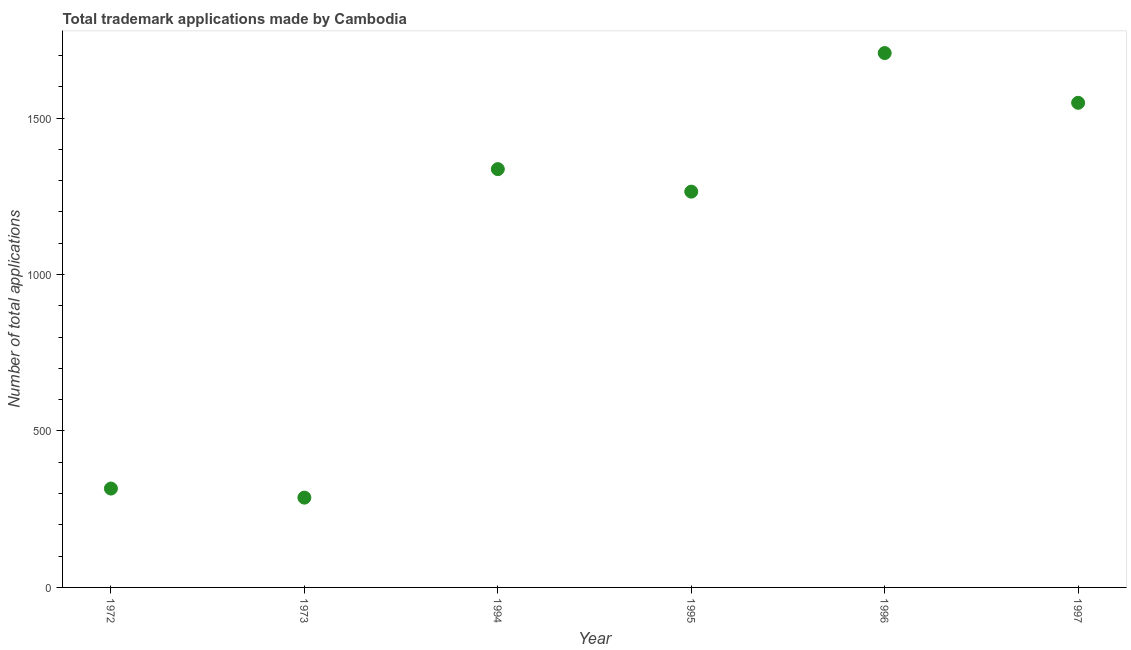What is the number of trademark applications in 1994?
Keep it short and to the point. 1337. Across all years, what is the maximum number of trademark applications?
Your answer should be compact. 1708. Across all years, what is the minimum number of trademark applications?
Offer a very short reply. 287. In which year was the number of trademark applications minimum?
Your answer should be very brief. 1973. What is the sum of the number of trademark applications?
Offer a terse response. 6462. What is the difference between the number of trademark applications in 1972 and 1997?
Provide a succinct answer. -1233. What is the average number of trademark applications per year?
Provide a succinct answer. 1077. What is the median number of trademark applications?
Keep it short and to the point. 1301. In how many years, is the number of trademark applications greater than 1000 ?
Your answer should be compact. 4. Do a majority of the years between 1994 and 1995 (inclusive) have number of trademark applications greater than 200 ?
Your response must be concise. Yes. What is the ratio of the number of trademark applications in 1972 to that in 1994?
Provide a short and direct response. 0.24. Is the number of trademark applications in 1972 less than that in 1995?
Offer a terse response. Yes. Is the difference between the number of trademark applications in 1996 and 1997 greater than the difference between any two years?
Your response must be concise. No. What is the difference between the highest and the second highest number of trademark applications?
Provide a succinct answer. 159. Is the sum of the number of trademark applications in 1972 and 1997 greater than the maximum number of trademark applications across all years?
Your response must be concise. Yes. What is the difference between the highest and the lowest number of trademark applications?
Ensure brevity in your answer.  1421. Does the number of trademark applications monotonically increase over the years?
Give a very brief answer. No. Does the graph contain any zero values?
Offer a terse response. No. What is the title of the graph?
Make the answer very short. Total trademark applications made by Cambodia. What is the label or title of the X-axis?
Give a very brief answer. Year. What is the label or title of the Y-axis?
Make the answer very short. Number of total applications. What is the Number of total applications in 1972?
Ensure brevity in your answer.  316. What is the Number of total applications in 1973?
Keep it short and to the point. 287. What is the Number of total applications in 1994?
Your answer should be compact. 1337. What is the Number of total applications in 1995?
Make the answer very short. 1265. What is the Number of total applications in 1996?
Your response must be concise. 1708. What is the Number of total applications in 1997?
Keep it short and to the point. 1549. What is the difference between the Number of total applications in 1972 and 1994?
Your answer should be compact. -1021. What is the difference between the Number of total applications in 1972 and 1995?
Your response must be concise. -949. What is the difference between the Number of total applications in 1972 and 1996?
Offer a terse response. -1392. What is the difference between the Number of total applications in 1972 and 1997?
Offer a very short reply. -1233. What is the difference between the Number of total applications in 1973 and 1994?
Offer a terse response. -1050. What is the difference between the Number of total applications in 1973 and 1995?
Provide a short and direct response. -978. What is the difference between the Number of total applications in 1973 and 1996?
Offer a very short reply. -1421. What is the difference between the Number of total applications in 1973 and 1997?
Provide a short and direct response. -1262. What is the difference between the Number of total applications in 1994 and 1995?
Provide a short and direct response. 72. What is the difference between the Number of total applications in 1994 and 1996?
Provide a short and direct response. -371. What is the difference between the Number of total applications in 1994 and 1997?
Offer a very short reply. -212. What is the difference between the Number of total applications in 1995 and 1996?
Your answer should be very brief. -443. What is the difference between the Number of total applications in 1995 and 1997?
Make the answer very short. -284. What is the difference between the Number of total applications in 1996 and 1997?
Your answer should be compact. 159. What is the ratio of the Number of total applications in 1972 to that in 1973?
Give a very brief answer. 1.1. What is the ratio of the Number of total applications in 1972 to that in 1994?
Offer a very short reply. 0.24. What is the ratio of the Number of total applications in 1972 to that in 1996?
Provide a short and direct response. 0.18. What is the ratio of the Number of total applications in 1972 to that in 1997?
Your answer should be compact. 0.2. What is the ratio of the Number of total applications in 1973 to that in 1994?
Ensure brevity in your answer.  0.21. What is the ratio of the Number of total applications in 1973 to that in 1995?
Your answer should be very brief. 0.23. What is the ratio of the Number of total applications in 1973 to that in 1996?
Your answer should be very brief. 0.17. What is the ratio of the Number of total applications in 1973 to that in 1997?
Make the answer very short. 0.18. What is the ratio of the Number of total applications in 1994 to that in 1995?
Your answer should be compact. 1.06. What is the ratio of the Number of total applications in 1994 to that in 1996?
Provide a succinct answer. 0.78. What is the ratio of the Number of total applications in 1994 to that in 1997?
Make the answer very short. 0.86. What is the ratio of the Number of total applications in 1995 to that in 1996?
Make the answer very short. 0.74. What is the ratio of the Number of total applications in 1995 to that in 1997?
Ensure brevity in your answer.  0.82. What is the ratio of the Number of total applications in 1996 to that in 1997?
Your answer should be compact. 1.1. 